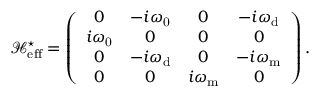Convert formula to latex. <formula><loc_0><loc_0><loc_500><loc_500>\mathcal { H } _ { e f f } ^ { ^ { * } } = \left ( \begin{array} { c c c c } { 0 } & { - i \omega _ { 0 } } & { 0 } & { - i \omega _ { d } } \\ { i \omega _ { 0 } } & { 0 } & { 0 } & { 0 } \\ { 0 } & { - i \omega _ { d } } & { 0 } & { - i { \omega } _ { m } } \\ { 0 } & { 0 } & { i { \omega } _ { m } } & { 0 } \end{array} \right ) .</formula> 